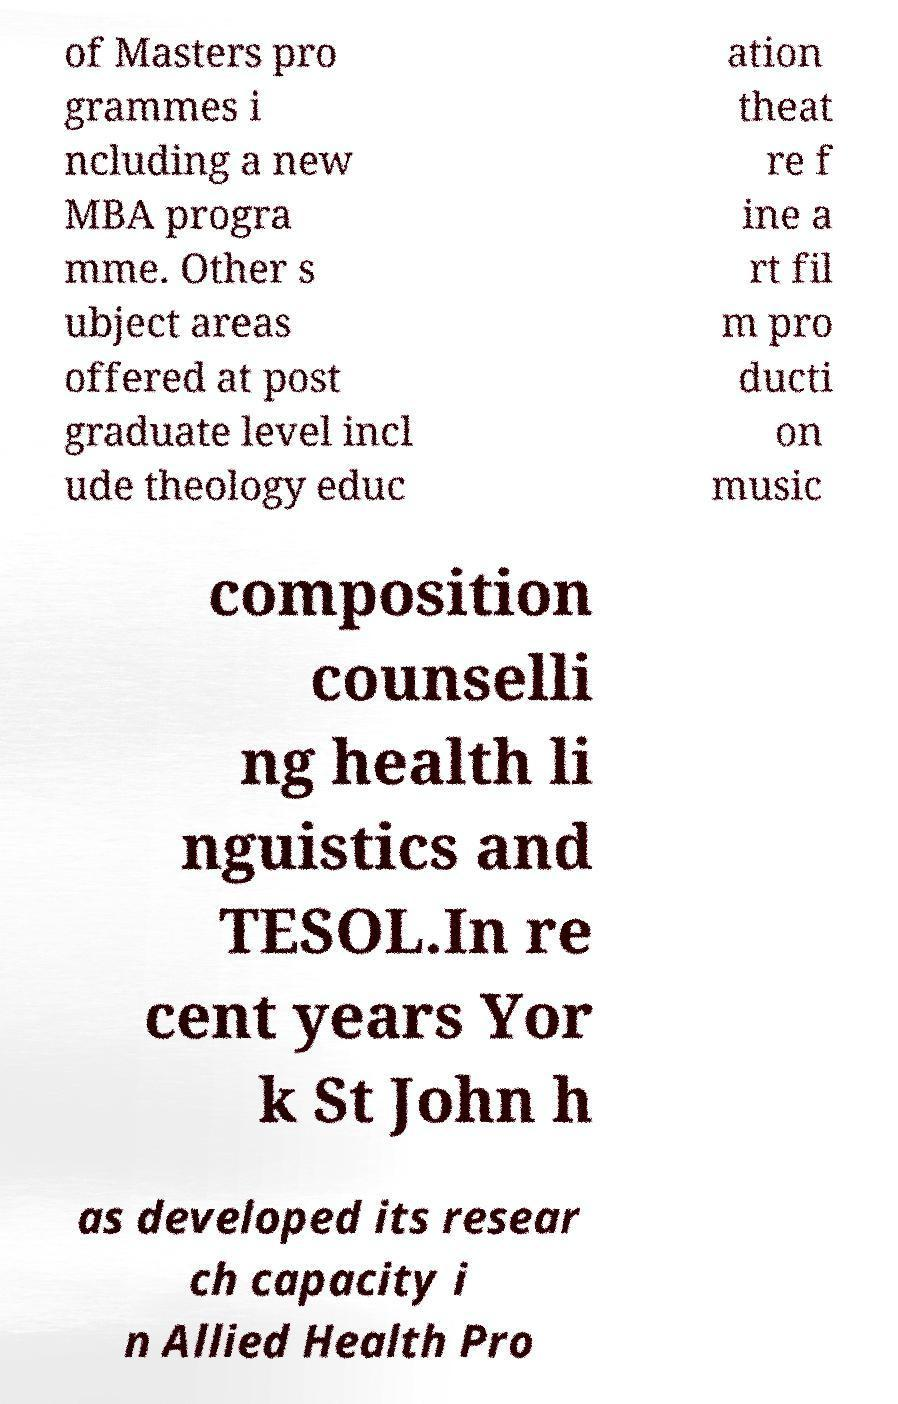Could you assist in decoding the text presented in this image and type it out clearly? of Masters pro grammes i ncluding a new MBA progra mme. Other s ubject areas offered at post graduate level incl ude theology educ ation theat re f ine a rt fil m pro ducti on music composition counselli ng health li nguistics and TESOL.In re cent years Yor k St John h as developed its resear ch capacity i n Allied Health Pro 